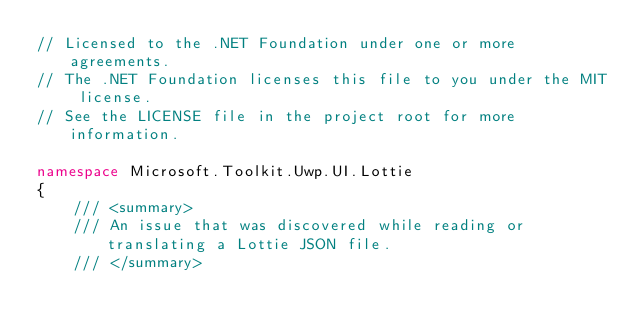Convert code to text. <code><loc_0><loc_0><loc_500><loc_500><_C#_>// Licensed to the .NET Foundation under one or more agreements.
// The .NET Foundation licenses this file to you under the MIT license.
// See the LICENSE file in the project root for more information.

namespace Microsoft.Toolkit.Uwp.UI.Lottie
{
    /// <summary>
    /// An issue that was discovered while reading or translating a Lottie JSON file.
    /// </summary></code> 